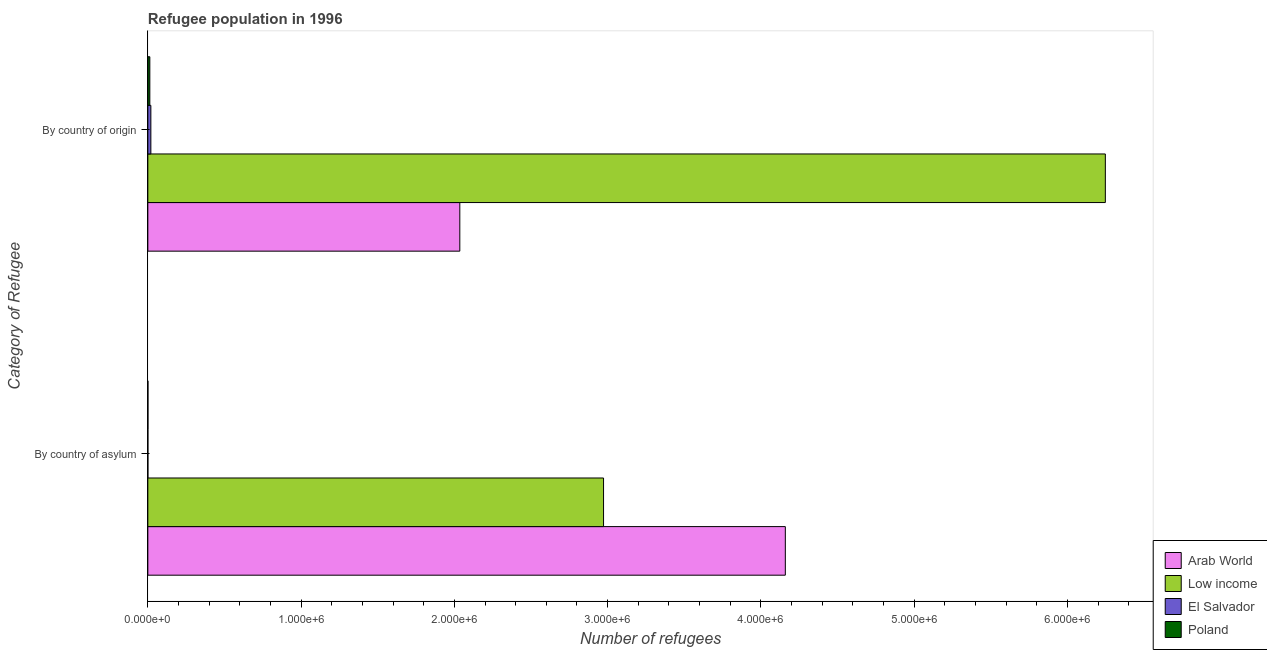How many different coloured bars are there?
Make the answer very short. 4. What is the label of the 1st group of bars from the top?
Provide a succinct answer. By country of origin. What is the number of refugees by country of asylum in Low income?
Give a very brief answer. 2.97e+06. Across all countries, what is the maximum number of refugees by country of origin?
Ensure brevity in your answer.  6.25e+06. Across all countries, what is the minimum number of refugees by country of asylum?
Offer a terse response. 150. In which country was the number of refugees by country of asylum maximum?
Offer a very short reply. Arab World. In which country was the number of refugees by country of asylum minimum?
Provide a succinct answer. El Salvador. What is the total number of refugees by country of origin in the graph?
Your answer should be very brief. 8.32e+06. What is the difference between the number of refugees by country of asylum in El Salvador and that in Low income?
Provide a succinct answer. -2.97e+06. What is the difference between the number of refugees by country of asylum in Poland and the number of refugees by country of origin in Low income?
Provide a short and direct response. -6.25e+06. What is the average number of refugees by country of asylum per country?
Your response must be concise. 1.78e+06. What is the difference between the number of refugees by country of origin and number of refugees by country of asylum in Low income?
Offer a terse response. 3.27e+06. What is the ratio of the number of refugees by country of asylum in Arab World to that in Poland?
Offer a very short reply. 6932.72. Is the number of refugees by country of origin in Arab World less than that in Low income?
Your answer should be very brief. Yes. What does the 4th bar from the top in By country of origin represents?
Your answer should be compact. Arab World. What does the 1st bar from the bottom in By country of origin represents?
Give a very brief answer. Arab World. Are all the bars in the graph horizontal?
Offer a very short reply. Yes. What is the difference between two consecutive major ticks on the X-axis?
Provide a succinct answer. 1.00e+06. Are the values on the major ticks of X-axis written in scientific E-notation?
Ensure brevity in your answer.  Yes. Where does the legend appear in the graph?
Keep it short and to the point. Bottom right. How many legend labels are there?
Offer a very short reply. 4. How are the legend labels stacked?
Ensure brevity in your answer.  Vertical. What is the title of the graph?
Your answer should be compact. Refugee population in 1996. Does "Cayman Islands" appear as one of the legend labels in the graph?
Your answer should be very brief. No. What is the label or title of the X-axis?
Offer a terse response. Number of refugees. What is the label or title of the Y-axis?
Provide a short and direct response. Category of Refugee. What is the Number of refugees in Arab World in By country of asylum?
Your answer should be very brief. 4.16e+06. What is the Number of refugees in Low income in By country of asylum?
Offer a very short reply. 2.97e+06. What is the Number of refugees of El Salvador in By country of asylum?
Provide a succinct answer. 150. What is the Number of refugees of Poland in By country of asylum?
Your answer should be compact. 600. What is the Number of refugees of Arab World in By country of origin?
Offer a terse response. 2.04e+06. What is the Number of refugees in Low income in By country of origin?
Ensure brevity in your answer.  6.25e+06. What is the Number of refugees of El Salvador in By country of origin?
Give a very brief answer. 1.96e+04. What is the Number of refugees of Poland in By country of origin?
Your answer should be very brief. 1.29e+04. Across all Category of Refugee, what is the maximum Number of refugees in Arab World?
Ensure brevity in your answer.  4.16e+06. Across all Category of Refugee, what is the maximum Number of refugees of Low income?
Your answer should be very brief. 6.25e+06. Across all Category of Refugee, what is the maximum Number of refugees of El Salvador?
Make the answer very short. 1.96e+04. Across all Category of Refugee, what is the maximum Number of refugees in Poland?
Make the answer very short. 1.29e+04. Across all Category of Refugee, what is the minimum Number of refugees in Arab World?
Offer a very short reply. 2.04e+06. Across all Category of Refugee, what is the minimum Number of refugees in Low income?
Make the answer very short. 2.97e+06. Across all Category of Refugee, what is the minimum Number of refugees of El Salvador?
Provide a succinct answer. 150. Across all Category of Refugee, what is the minimum Number of refugees in Poland?
Your answer should be very brief. 600. What is the total Number of refugees of Arab World in the graph?
Offer a terse response. 6.20e+06. What is the total Number of refugees in Low income in the graph?
Offer a very short reply. 9.22e+06. What is the total Number of refugees of El Salvador in the graph?
Give a very brief answer. 1.98e+04. What is the total Number of refugees in Poland in the graph?
Keep it short and to the point. 1.35e+04. What is the difference between the Number of refugees of Arab World in By country of asylum and that in By country of origin?
Provide a succinct answer. 2.12e+06. What is the difference between the Number of refugees of Low income in By country of asylum and that in By country of origin?
Offer a terse response. -3.27e+06. What is the difference between the Number of refugees in El Salvador in By country of asylum and that in By country of origin?
Make the answer very short. -1.95e+04. What is the difference between the Number of refugees in Poland in By country of asylum and that in By country of origin?
Make the answer very short. -1.23e+04. What is the difference between the Number of refugees in Arab World in By country of asylum and the Number of refugees in Low income in By country of origin?
Make the answer very short. -2.09e+06. What is the difference between the Number of refugees in Arab World in By country of asylum and the Number of refugees in El Salvador in By country of origin?
Your answer should be very brief. 4.14e+06. What is the difference between the Number of refugees of Arab World in By country of asylum and the Number of refugees of Poland in By country of origin?
Make the answer very short. 4.15e+06. What is the difference between the Number of refugees in Low income in By country of asylum and the Number of refugees in El Salvador in By country of origin?
Offer a terse response. 2.95e+06. What is the difference between the Number of refugees in Low income in By country of asylum and the Number of refugees in Poland in By country of origin?
Provide a succinct answer. 2.96e+06. What is the difference between the Number of refugees in El Salvador in By country of asylum and the Number of refugees in Poland in By country of origin?
Your answer should be compact. -1.27e+04. What is the average Number of refugees in Arab World per Category of Refugee?
Your answer should be very brief. 3.10e+06. What is the average Number of refugees of Low income per Category of Refugee?
Keep it short and to the point. 4.61e+06. What is the average Number of refugees of El Salvador per Category of Refugee?
Offer a very short reply. 9894.5. What is the average Number of refugees in Poland per Category of Refugee?
Offer a very short reply. 6734.5. What is the difference between the Number of refugees of Arab World and Number of refugees of Low income in By country of asylum?
Ensure brevity in your answer.  1.19e+06. What is the difference between the Number of refugees of Arab World and Number of refugees of El Salvador in By country of asylum?
Give a very brief answer. 4.16e+06. What is the difference between the Number of refugees of Arab World and Number of refugees of Poland in By country of asylum?
Ensure brevity in your answer.  4.16e+06. What is the difference between the Number of refugees of Low income and Number of refugees of El Salvador in By country of asylum?
Provide a succinct answer. 2.97e+06. What is the difference between the Number of refugees in Low income and Number of refugees in Poland in By country of asylum?
Your response must be concise. 2.97e+06. What is the difference between the Number of refugees in El Salvador and Number of refugees in Poland in By country of asylum?
Provide a succinct answer. -450. What is the difference between the Number of refugees in Arab World and Number of refugees in Low income in By country of origin?
Your answer should be compact. -4.21e+06. What is the difference between the Number of refugees in Arab World and Number of refugees in El Salvador in By country of origin?
Give a very brief answer. 2.02e+06. What is the difference between the Number of refugees in Arab World and Number of refugees in Poland in By country of origin?
Provide a succinct answer. 2.02e+06. What is the difference between the Number of refugees of Low income and Number of refugees of El Salvador in By country of origin?
Your answer should be compact. 6.23e+06. What is the difference between the Number of refugees of Low income and Number of refugees of Poland in By country of origin?
Provide a succinct answer. 6.23e+06. What is the difference between the Number of refugees of El Salvador and Number of refugees of Poland in By country of origin?
Ensure brevity in your answer.  6770. What is the ratio of the Number of refugees of Arab World in By country of asylum to that in By country of origin?
Keep it short and to the point. 2.04. What is the ratio of the Number of refugees of Low income in By country of asylum to that in By country of origin?
Provide a succinct answer. 0.48. What is the ratio of the Number of refugees in El Salvador in By country of asylum to that in By country of origin?
Make the answer very short. 0.01. What is the ratio of the Number of refugees in Poland in By country of asylum to that in By country of origin?
Provide a short and direct response. 0.05. What is the difference between the highest and the second highest Number of refugees in Arab World?
Your response must be concise. 2.12e+06. What is the difference between the highest and the second highest Number of refugees in Low income?
Your answer should be very brief. 3.27e+06. What is the difference between the highest and the second highest Number of refugees of El Salvador?
Offer a very short reply. 1.95e+04. What is the difference between the highest and the second highest Number of refugees in Poland?
Make the answer very short. 1.23e+04. What is the difference between the highest and the lowest Number of refugees of Arab World?
Your answer should be compact. 2.12e+06. What is the difference between the highest and the lowest Number of refugees in Low income?
Keep it short and to the point. 3.27e+06. What is the difference between the highest and the lowest Number of refugees of El Salvador?
Ensure brevity in your answer.  1.95e+04. What is the difference between the highest and the lowest Number of refugees of Poland?
Provide a succinct answer. 1.23e+04. 